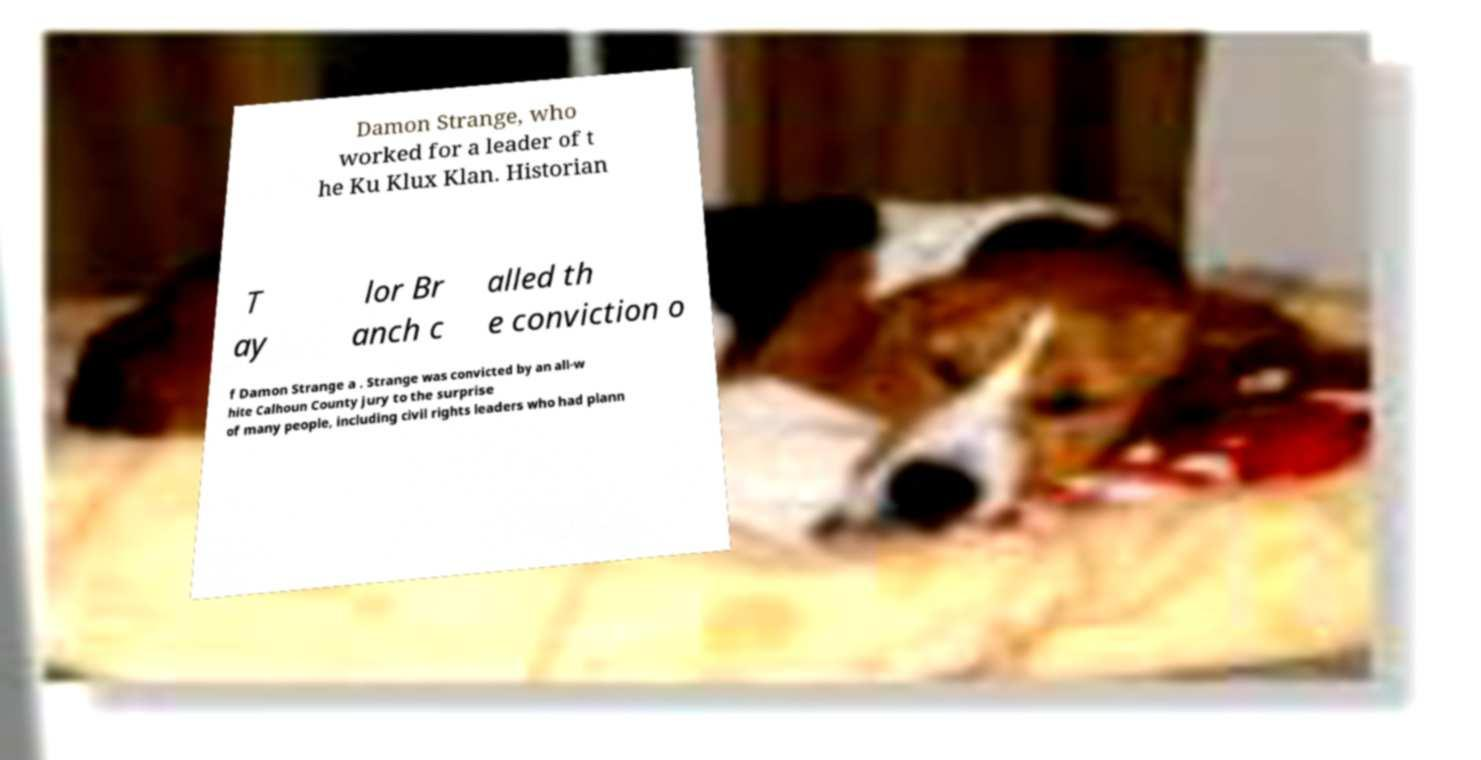Can you read and provide the text displayed in the image?This photo seems to have some interesting text. Can you extract and type it out for me? Damon Strange, who worked for a leader of t he Ku Klux Klan. Historian T ay lor Br anch c alled th e conviction o f Damon Strange a . Strange was convicted by an all-w hite Calhoun County jury to the surprise of many people, including civil rights leaders who had plann 